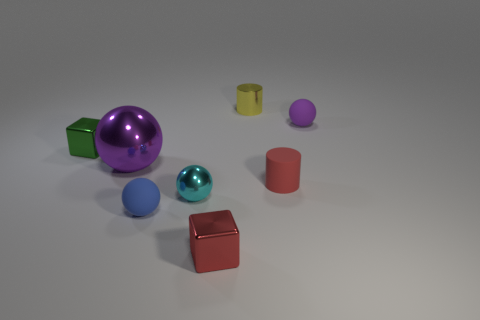Is the color of the big ball the same as the small rubber object that is right of the tiny red matte thing?
Make the answer very short. Yes. There is a small rubber sphere behind the small blue rubber thing; is its color the same as the large shiny sphere?
Your answer should be compact. Yes. The thing that is the same color as the big ball is what size?
Offer a very short reply. Small. How many cubes are behind the tiny rubber sphere behind the block that is behind the large thing?
Offer a terse response. 0. Is there a small matte object that has the same color as the big object?
Provide a succinct answer. Yes. What is the color of the matte cylinder that is the same size as the purple matte thing?
Keep it short and to the point. Red. Are there any other tiny objects of the same shape as the tiny purple rubber object?
Provide a short and direct response. Yes. There is a rubber object that is the same color as the big metal sphere; what is its shape?
Provide a succinct answer. Sphere. There is a purple object to the right of the tiny red thing behind the small red block; is there a cylinder behind it?
Your response must be concise. Yes. The red metallic thing that is the same size as the green shiny object is what shape?
Give a very brief answer. Cube. 